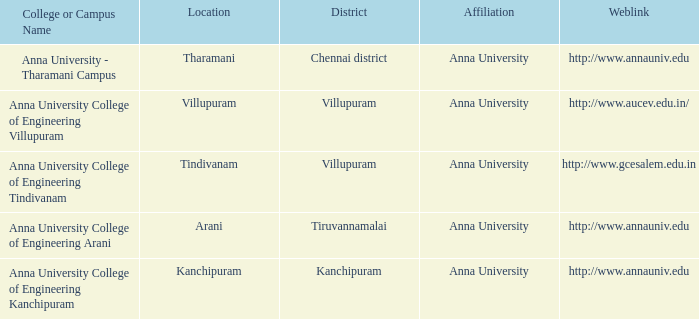What Weblink has a College or Campus Name of anna university college of engineering tindivanam? Http://www.gcesalem.edu.in. 